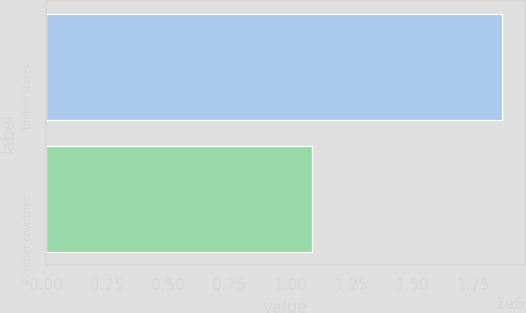Convert chart. <chart><loc_0><loc_0><loc_500><loc_500><bar_chart><fcel>United States<fcel>All other countries<nl><fcel>1.866e+06<fcel>1.08943e+06<nl></chart> 